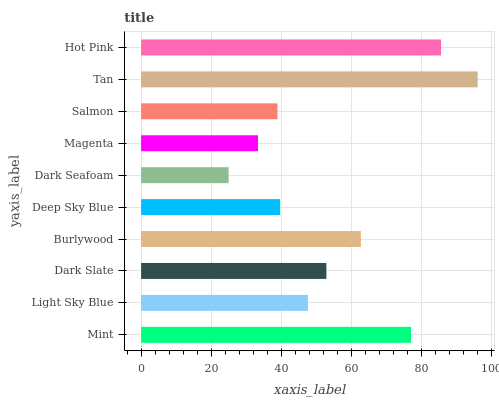Is Dark Seafoam the minimum?
Answer yes or no. Yes. Is Tan the maximum?
Answer yes or no. Yes. Is Light Sky Blue the minimum?
Answer yes or no. No. Is Light Sky Blue the maximum?
Answer yes or no. No. Is Mint greater than Light Sky Blue?
Answer yes or no. Yes. Is Light Sky Blue less than Mint?
Answer yes or no. Yes. Is Light Sky Blue greater than Mint?
Answer yes or no. No. Is Mint less than Light Sky Blue?
Answer yes or no. No. Is Dark Slate the high median?
Answer yes or no. Yes. Is Light Sky Blue the low median?
Answer yes or no. Yes. Is Magenta the high median?
Answer yes or no. No. Is Hot Pink the low median?
Answer yes or no. No. 